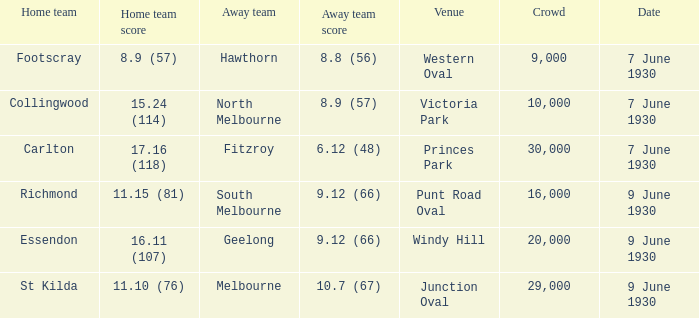12 (66) at windy hill? Geelong. 